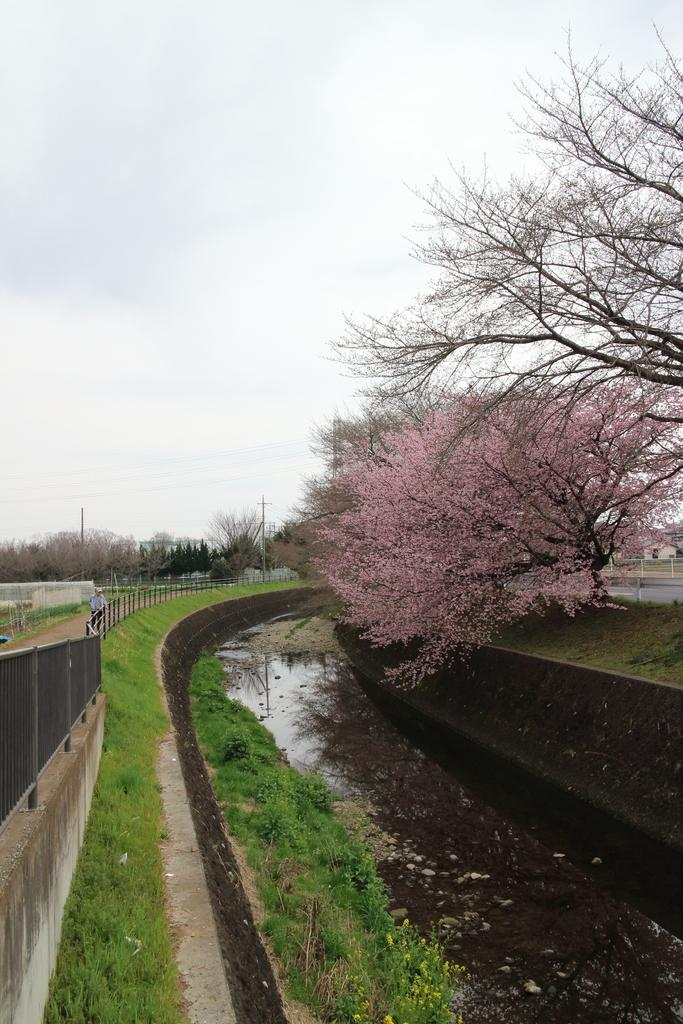What is visible in the image? Water is visible in the image. What can be seen on the right side of the water? There are trees on the right side of the water. What type of vegetation is on the left side of the image? There is grass on the left side of the image. What architectural feature is present on the left side of the image? There is a fence on the left side of the image. How many frogs are jumping in the water in the image? There are no frogs visible in the image; it only shows water, trees, grass, and a fence. 